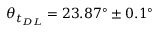<formula> <loc_0><loc_0><loc_500><loc_500>\theta _ { t _ { D L } } = 2 3 . 8 7 ^ { \circ } \pm 0 . 1 ^ { \circ }</formula> 